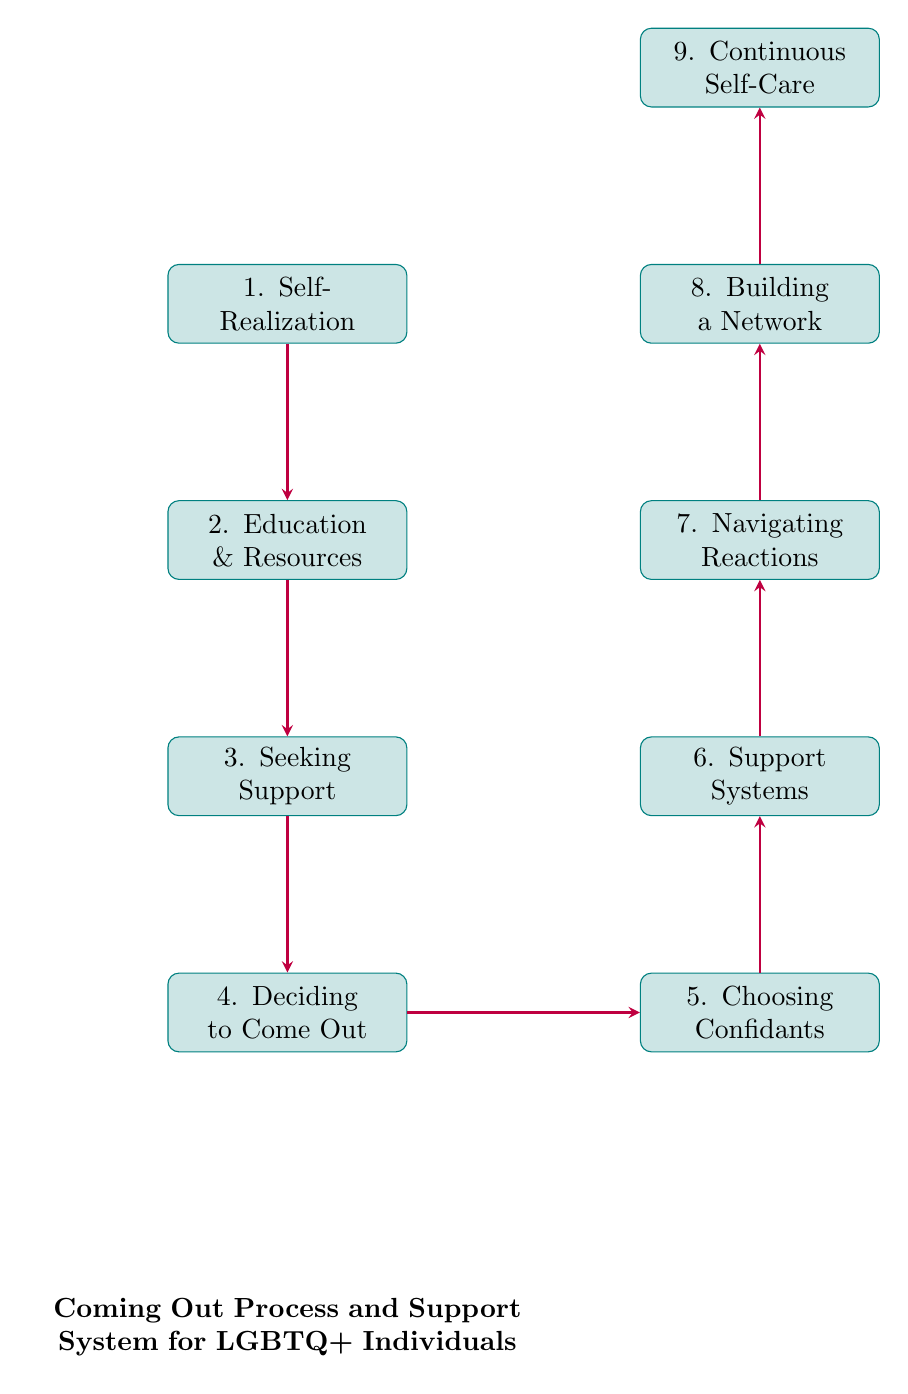What is the first step in the coming out process? The diagram shows that the first node in the flow chart is "Self-Realization." This indicates that understanding one's sexual orientation or gender identity is the starting point.
Answer: Self-Realization How many nodes are in the diagram? By counting each of the individual steps listed in the nodes section of the diagram, there are a total of nine distinct nodes.
Answer: 9 What is the last node listed in the process? The final step in the flow of the diagram is "Continuous Self-Care," representing ongoing mental and emotional well-being practices.
Answer: Continuous Self-Care Which node follows "Choosing Confidants"? Looking at the flow of the diagram, the node that comes directly after "Choosing Confidants" is "Support Systems," indicating the next step in finding support.
Answer: Support Systems What is the relationship between "Seeking Support" and "Navigating Reactions"? To find the relationship, we look at the directed arrows. "Seeking Support" leads to "Deciding to Come Out," which connects downstream to "Navigating Reactions," indicating a supportive transition through the steps.
Answer: Indirect connection What comes after "Support Systems" in the flow chart? The flow indicates that after "Support Systems," the next step is "Navigating Reactions," which involves handling people's reactions with the help of allies.
Answer: Navigating Reactions Which node is connected to both "Deciding to Come Out" and "Choosing Confidants"? The node "Support Systems" is directly connected to "Choosing Confidants," while "Deciding to Come Out" leads to "Choosing Confidants," highlighting its significance in the support process.
Answer: Support Systems How does "Building a Network" relate to "Continuous Self-Care"? "Building a Network" leads to "Continuous Self-Care," indicating that having a supportive network directly contributes to ongoing self-care practices for mental and emotional health.
Answer: Direct connection What is the node immediately before "Building a Network"? The diagram shows that the node right before "Building a Network" is "Navigating Reactions," highlighting the importance of support through various responses from others.
Answer: Navigating Reactions 